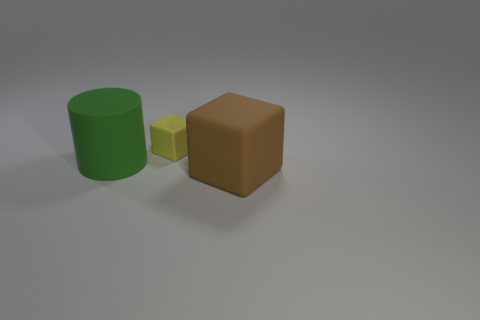Add 1 cyan objects. How many objects exist? 4 Subtract all cylinders. How many objects are left? 2 Add 1 small objects. How many small objects exist? 2 Subtract 0 yellow cylinders. How many objects are left? 3 Subtract all big cylinders. Subtract all large blue spheres. How many objects are left? 2 Add 1 things. How many things are left? 4 